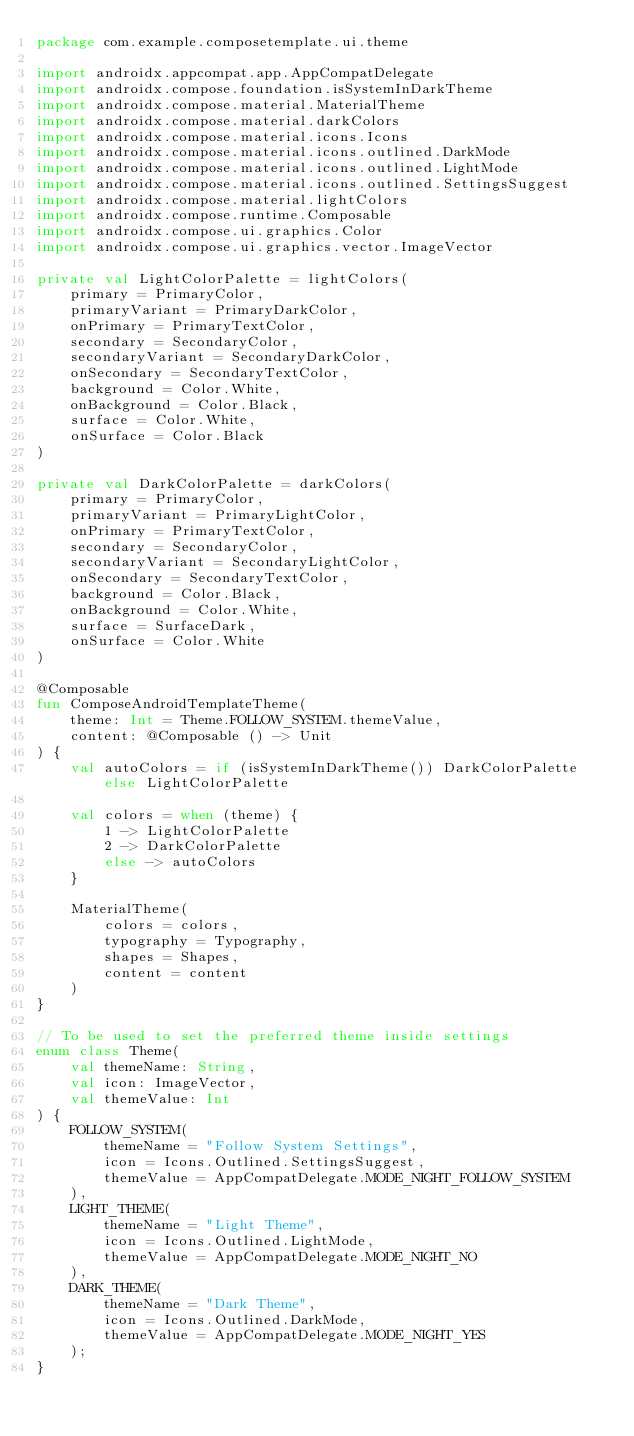Convert code to text. <code><loc_0><loc_0><loc_500><loc_500><_Kotlin_>package com.example.composetemplate.ui.theme

import androidx.appcompat.app.AppCompatDelegate
import androidx.compose.foundation.isSystemInDarkTheme
import androidx.compose.material.MaterialTheme
import androidx.compose.material.darkColors
import androidx.compose.material.icons.Icons
import androidx.compose.material.icons.outlined.DarkMode
import androidx.compose.material.icons.outlined.LightMode
import androidx.compose.material.icons.outlined.SettingsSuggest
import androidx.compose.material.lightColors
import androidx.compose.runtime.Composable
import androidx.compose.ui.graphics.Color
import androidx.compose.ui.graphics.vector.ImageVector

private val LightColorPalette = lightColors(
    primary = PrimaryColor,
    primaryVariant = PrimaryDarkColor,
    onPrimary = PrimaryTextColor,
    secondary = SecondaryColor,
    secondaryVariant = SecondaryDarkColor,
    onSecondary = SecondaryTextColor,
    background = Color.White,
    onBackground = Color.Black,
    surface = Color.White,
    onSurface = Color.Black
)

private val DarkColorPalette = darkColors(
    primary = PrimaryColor,
    primaryVariant = PrimaryLightColor,
    onPrimary = PrimaryTextColor,
    secondary = SecondaryColor,
    secondaryVariant = SecondaryLightColor,
    onSecondary = SecondaryTextColor,
    background = Color.Black,
    onBackground = Color.White,
    surface = SurfaceDark,
    onSurface = Color.White
)

@Composable
fun ComposeAndroidTemplateTheme(
    theme: Int = Theme.FOLLOW_SYSTEM.themeValue,
    content: @Composable () -> Unit
) {
    val autoColors = if (isSystemInDarkTheme()) DarkColorPalette else LightColorPalette

    val colors = when (theme) {
        1 -> LightColorPalette
        2 -> DarkColorPalette
        else -> autoColors
    }

    MaterialTheme(
        colors = colors,
        typography = Typography,
        shapes = Shapes,
        content = content
    )
}

// To be used to set the preferred theme inside settings
enum class Theme(
    val themeName: String,
    val icon: ImageVector,
    val themeValue: Int
) {
    FOLLOW_SYSTEM(
        themeName = "Follow System Settings",
        icon = Icons.Outlined.SettingsSuggest,
        themeValue = AppCompatDelegate.MODE_NIGHT_FOLLOW_SYSTEM
    ),
    LIGHT_THEME(
        themeName = "Light Theme",
        icon = Icons.Outlined.LightMode,
        themeValue = AppCompatDelegate.MODE_NIGHT_NO
    ),
    DARK_THEME(
        themeName = "Dark Theme",
        icon = Icons.Outlined.DarkMode,
        themeValue = AppCompatDelegate.MODE_NIGHT_YES
    );
}
</code> 